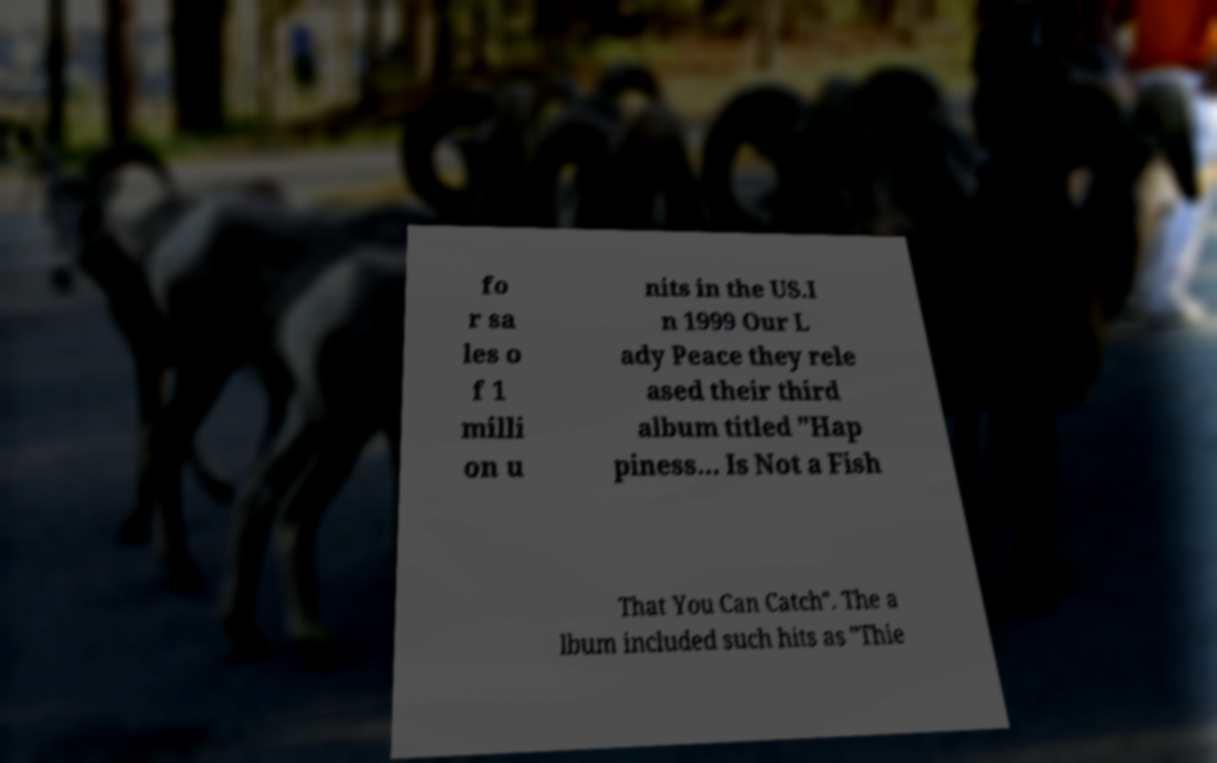Can you read and provide the text displayed in the image?This photo seems to have some interesting text. Can you extract and type it out for me? fo r sa les o f 1 milli on u nits in the US.I n 1999 Our L ady Peace they rele ased their third album titled "Hap piness... Is Not a Fish That You Can Catch". The a lbum included such hits as "Thie 